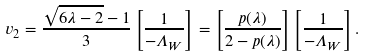Convert formula to latex. <formula><loc_0><loc_0><loc_500><loc_500>v _ { 2 } = \frac { \sqrt { 6 \lambda - 2 } - 1 } { 3 } \left [ \frac { 1 } { - \Lambda _ { W } } \right ] = \left [ \frac { p ( \lambda ) } { 2 - p ( \lambda ) } \right ] \left [ \frac { 1 } { - \Lambda _ { W } } \right ] .</formula> 